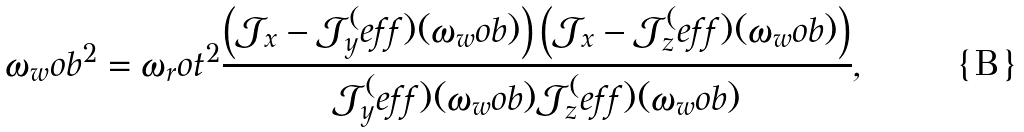<formula> <loc_0><loc_0><loc_500><loc_500>\omega _ { w } o b ^ { 2 } = \omega _ { r } o t ^ { 2 } \frac { \left ( \mathcal { J } _ { x } - \mathcal { J } _ { y } ^ { ( } e f f ) ( \omega _ { w } o b ) \right ) \left ( \mathcal { J } _ { x } - \mathcal { J } _ { z } ^ { ( } e f f ) ( \omega _ { w } o b ) \right ) } { \mathcal { J } _ { y } ^ { ( } e f f ) ( \omega _ { w } o b ) \mathcal { J } _ { z } ^ { ( } e f f ) ( \omega _ { w } o b ) } ,</formula> 